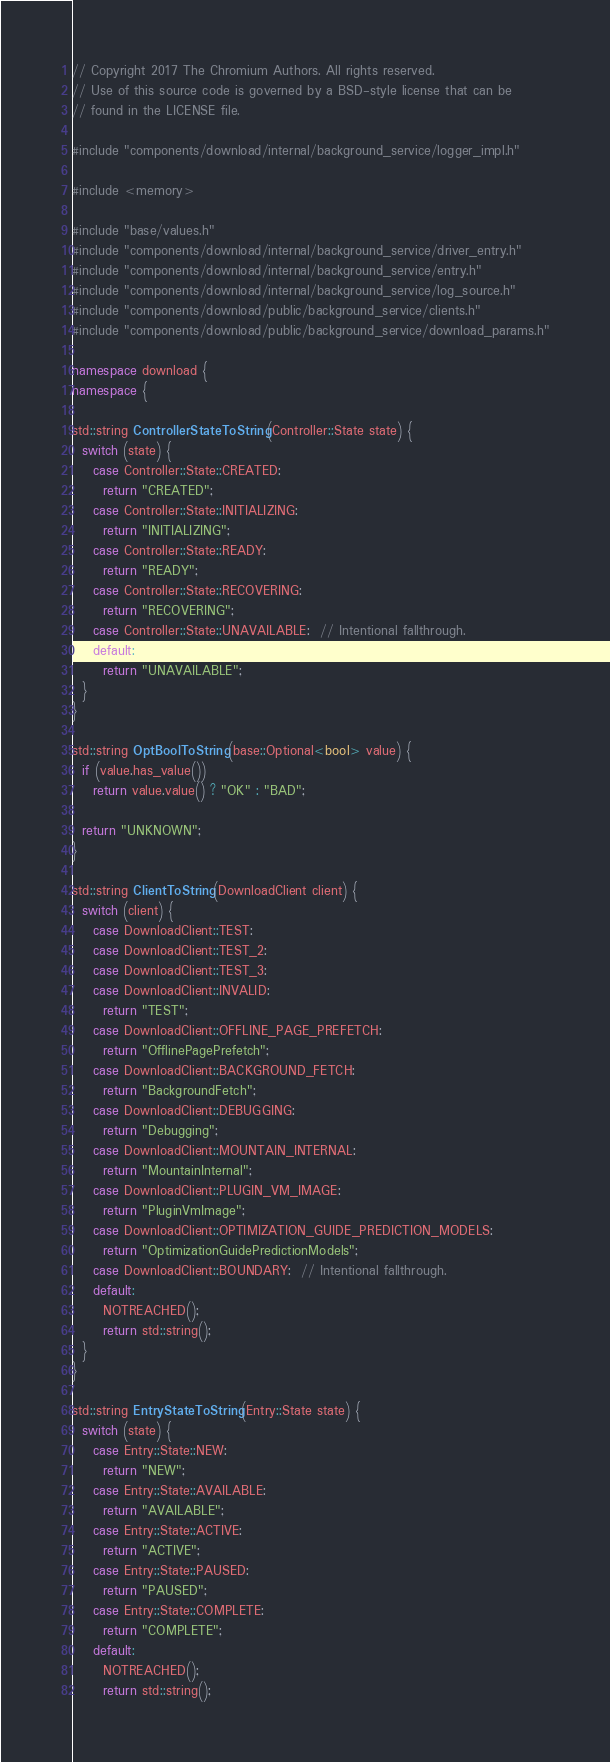<code> <loc_0><loc_0><loc_500><loc_500><_C++_>// Copyright 2017 The Chromium Authors. All rights reserved.
// Use of this source code is governed by a BSD-style license that can be
// found in the LICENSE file.

#include "components/download/internal/background_service/logger_impl.h"

#include <memory>

#include "base/values.h"
#include "components/download/internal/background_service/driver_entry.h"
#include "components/download/internal/background_service/entry.h"
#include "components/download/internal/background_service/log_source.h"
#include "components/download/public/background_service/clients.h"
#include "components/download/public/background_service/download_params.h"

namespace download {
namespace {

std::string ControllerStateToString(Controller::State state) {
  switch (state) {
    case Controller::State::CREATED:
      return "CREATED";
    case Controller::State::INITIALIZING:
      return "INITIALIZING";
    case Controller::State::READY:
      return "READY";
    case Controller::State::RECOVERING:
      return "RECOVERING";
    case Controller::State::UNAVAILABLE:  // Intentional fallthrough.
    default:
      return "UNAVAILABLE";
  }
}

std::string OptBoolToString(base::Optional<bool> value) {
  if (value.has_value())
    return value.value() ? "OK" : "BAD";

  return "UNKNOWN";
}

std::string ClientToString(DownloadClient client) {
  switch (client) {
    case DownloadClient::TEST:
    case DownloadClient::TEST_2:
    case DownloadClient::TEST_3:
    case DownloadClient::INVALID:
      return "TEST";
    case DownloadClient::OFFLINE_PAGE_PREFETCH:
      return "OfflinePagePrefetch";
    case DownloadClient::BACKGROUND_FETCH:
      return "BackgroundFetch";
    case DownloadClient::DEBUGGING:
      return "Debugging";
    case DownloadClient::MOUNTAIN_INTERNAL:
      return "MountainInternal";
    case DownloadClient::PLUGIN_VM_IMAGE:
      return "PluginVmImage";
    case DownloadClient::OPTIMIZATION_GUIDE_PREDICTION_MODELS:
      return "OptimizationGuidePredictionModels";
    case DownloadClient::BOUNDARY:  // Intentional fallthrough.
    default:
      NOTREACHED();
      return std::string();
  }
}

std::string EntryStateToString(Entry::State state) {
  switch (state) {
    case Entry::State::NEW:
      return "NEW";
    case Entry::State::AVAILABLE:
      return "AVAILABLE";
    case Entry::State::ACTIVE:
      return "ACTIVE";
    case Entry::State::PAUSED:
      return "PAUSED";
    case Entry::State::COMPLETE:
      return "COMPLETE";
    default:
      NOTREACHED();
      return std::string();</code> 